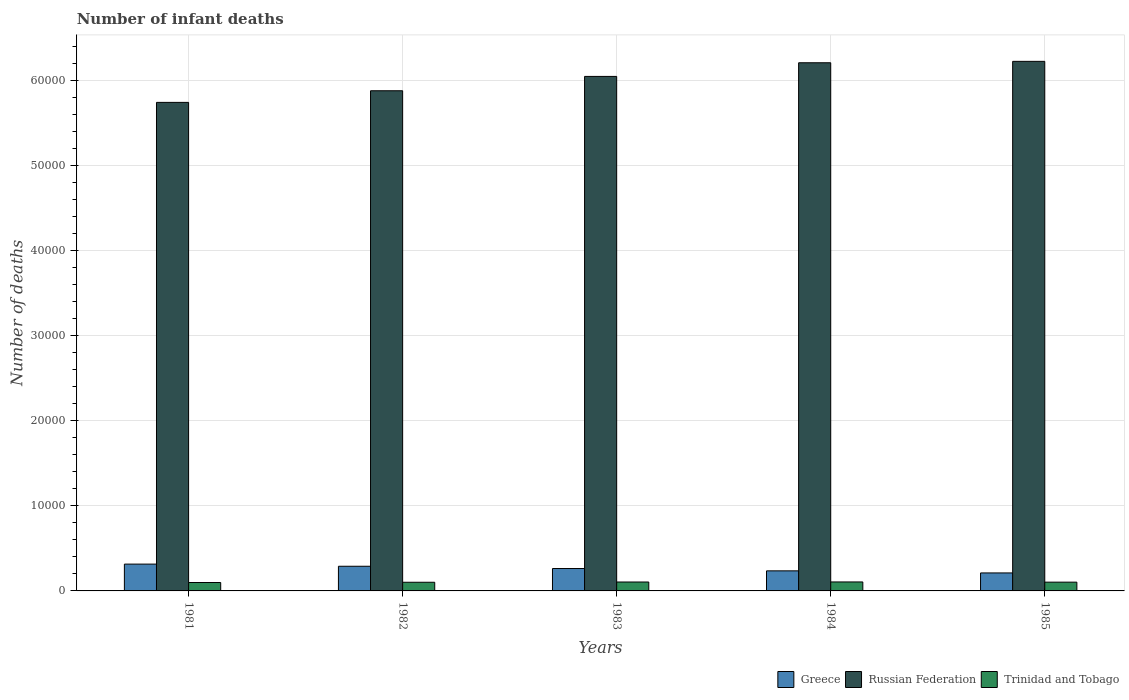How many groups of bars are there?
Keep it short and to the point. 5. Are the number of bars per tick equal to the number of legend labels?
Offer a terse response. Yes. How many bars are there on the 4th tick from the left?
Your response must be concise. 3. What is the number of infant deaths in Greece in 1983?
Your answer should be compact. 2634. Across all years, what is the maximum number of infant deaths in Russian Federation?
Make the answer very short. 6.23e+04. Across all years, what is the minimum number of infant deaths in Greece?
Keep it short and to the point. 2116. What is the total number of infant deaths in Trinidad and Tobago in the graph?
Keep it short and to the point. 5144. What is the difference between the number of infant deaths in Russian Federation in 1981 and that in 1984?
Make the answer very short. -4660. What is the difference between the number of infant deaths in Russian Federation in 1981 and the number of infant deaths in Trinidad and Tobago in 1983?
Keep it short and to the point. 5.64e+04. What is the average number of infant deaths in Greece per year?
Provide a short and direct response. 2633. In the year 1981, what is the difference between the number of infant deaths in Greece and number of infant deaths in Trinidad and Tobago?
Ensure brevity in your answer.  2164. What is the ratio of the number of infant deaths in Greece in 1982 to that in 1983?
Provide a succinct answer. 1.1. Is the number of infant deaths in Trinidad and Tobago in 1982 less than that in 1983?
Your answer should be compact. Yes. Is the difference between the number of infant deaths in Greece in 1982 and 1983 greater than the difference between the number of infant deaths in Trinidad and Tobago in 1982 and 1983?
Your answer should be compact. Yes. What is the difference between the highest and the second highest number of infant deaths in Russian Federation?
Your answer should be very brief. 165. What is the difference between the highest and the lowest number of infant deaths in Russian Federation?
Keep it short and to the point. 4825. In how many years, is the number of infant deaths in Trinidad and Tobago greater than the average number of infant deaths in Trinidad and Tobago taken over all years?
Your response must be concise. 3. What does the 3rd bar from the left in 1985 represents?
Offer a terse response. Trinidad and Tobago. What does the 2nd bar from the right in 1985 represents?
Offer a very short reply. Russian Federation. Is it the case that in every year, the sum of the number of infant deaths in Greece and number of infant deaths in Trinidad and Tobago is greater than the number of infant deaths in Russian Federation?
Make the answer very short. No. How many years are there in the graph?
Provide a succinct answer. 5. What is the difference between two consecutive major ticks on the Y-axis?
Keep it short and to the point. 10000. Are the values on the major ticks of Y-axis written in scientific E-notation?
Your response must be concise. No. Does the graph contain any zero values?
Your answer should be compact. No. Does the graph contain grids?
Your answer should be compact. Yes. How many legend labels are there?
Keep it short and to the point. 3. How are the legend labels stacked?
Ensure brevity in your answer.  Horizontal. What is the title of the graph?
Offer a very short reply. Number of infant deaths. Does "Venezuela" appear as one of the legend labels in the graph?
Keep it short and to the point. No. What is the label or title of the X-axis?
Your answer should be compact. Years. What is the label or title of the Y-axis?
Your answer should be very brief. Number of deaths. What is the Number of deaths in Greece in 1981?
Your answer should be compact. 3154. What is the Number of deaths of Russian Federation in 1981?
Make the answer very short. 5.75e+04. What is the Number of deaths in Trinidad and Tobago in 1981?
Ensure brevity in your answer.  990. What is the Number of deaths of Greece in 1982?
Ensure brevity in your answer.  2901. What is the Number of deaths in Russian Federation in 1982?
Keep it short and to the point. 5.88e+04. What is the Number of deaths of Trinidad and Tobago in 1982?
Give a very brief answer. 1019. What is the Number of deaths of Greece in 1983?
Your answer should be compact. 2634. What is the Number of deaths of Russian Federation in 1983?
Make the answer very short. 6.05e+04. What is the Number of deaths of Trinidad and Tobago in 1983?
Provide a short and direct response. 1049. What is the Number of deaths of Greece in 1984?
Your answer should be compact. 2360. What is the Number of deaths of Russian Federation in 1984?
Give a very brief answer. 6.21e+04. What is the Number of deaths of Trinidad and Tobago in 1984?
Offer a terse response. 1055. What is the Number of deaths of Greece in 1985?
Keep it short and to the point. 2116. What is the Number of deaths in Russian Federation in 1985?
Provide a succinct answer. 6.23e+04. What is the Number of deaths of Trinidad and Tobago in 1985?
Provide a short and direct response. 1031. Across all years, what is the maximum Number of deaths of Greece?
Ensure brevity in your answer.  3154. Across all years, what is the maximum Number of deaths in Russian Federation?
Your response must be concise. 6.23e+04. Across all years, what is the maximum Number of deaths in Trinidad and Tobago?
Your response must be concise. 1055. Across all years, what is the minimum Number of deaths in Greece?
Offer a terse response. 2116. Across all years, what is the minimum Number of deaths in Russian Federation?
Make the answer very short. 5.75e+04. Across all years, what is the minimum Number of deaths in Trinidad and Tobago?
Offer a very short reply. 990. What is the total Number of deaths of Greece in the graph?
Ensure brevity in your answer.  1.32e+04. What is the total Number of deaths of Russian Federation in the graph?
Provide a succinct answer. 3.01e+05. What is the total Number of deaths in Trinidad and Tobago in the graph?
Make the answer very short. 5144. What is the difference between the Number of deaths in Greece in 1981 and that in 1982?
Give a very brief answer. 253. What is the difference between the Number of deaths in Russian Federation in 1981 and that in 1982?
Your answer should be compact. -1367. What is the difference between the Number of deaths in Trinidad and Tobago in 1981 and that in 1982?
Provide a succinct answer. -29. What is the difference between the Number of deaths in Greece in 1981 and that in 1983?
Make the answer very short. 520. What is the difference between the Number of deaths in Russian Federation in 1981 and that in 1983?
Your answer should be compact. -3054. What is the difference between the Number of deaths in Trinidad and Tobago in 1981 and that in 1983?
Provide a short and direct response. -59. What is the difference between the Number of deaths in Greece in 1981 and that in 1984?
Provide a short and direct response. 794. What is the difference between the Number of deaths of Russian Federation in 1981 and that in 1984?
Give a very brief answer. -4660. What is the difference between the Number of deaths in Trinidad and Tobago in 1981 and that in 1984?
Your answer should be compact. -65. What is the difference between the Number of deaths in Greece in 1981 and that in 1985?
Your response must be concise. 1038. What is the difference between the Number of deaths of Russian Federation in 1981 and that in 1985?
Offer a terse response. -4825. What is the difference between the Number of deaths of Trinidad and Tobago in 1981 and that in 1985?
Keep it short and to the point. -41. What is the difference between the Number of deaths of Greece in 1982 and that in 1983?
Give a very brief answer. 267. What is the difference between the Number of deaths in Russian Federation in 1982 and that in 1983?
Provide a succinct answer. -1687. What is the difference between the Number of deaths in Greece in 1982 and that in 1984?
Ensure brevity in your answer.  541. What is the difference between the Number of deaths of Russian Federation in 1982 and that in 1984?
Your answer should be very brief. -3293. What is the difference between the Number of deaths of Trinidad and Tobago in 1982 and that in 1984?
Your answer should be very brief. -36. What is the difference between the Number of deaths of Greece in 1982 and that in 1985?
Ensure brevity in your answer.  785. What is the difference between the Number of deaths in Russian Federation in 1982 and that in 1985?
Your response must be concise. -3458. What is the difference between the Number of deaths in Greece in 1983 and that in 1984?
Provide a short and direct response. 274. What is the difference between the Number of deaths in Russian Federation in 1983 and that in 1984?
Make the answer very short. -1606. What is the difference between the Number of deaths of Trinidad and Tobago in 1983 and that in 1984?
Make the answer very short. -6. What is the difference between the Number of deaths in Greece in 1983 and that in 1985?
Offer a terse response. 518. What is the difference between the Number of deaths in Russian Federation in 1983 and that in 1985?
Provide a succinct answer. -1771. What is the difference between the Number of deaths in Trinidad and Tobago in 1983 and that in 1985?
Make the answer very short. 18. What is the difference between the Number of deaths in Greece in 1984 and that in 1985?
Your answer should be compact. 244. What is the difference between the Number of deaths of Russian Federation in 1984 and that in 1985?
Provide a short and direct response. -165. What is the difference between the Number of deaths in Trinidad and Tobago in 1984 and that in 1985?
Your answer should be very brief. 24. What is the difference between the Number of deaths in Greece in 1981 and the Number of deaths in Russian Federation in 1982?
Offer a terse response. -5.57e+04. What is the difference between the Number of deaths of Greece in 1981 and the Number of deaths of Trinidad and Tobago in 1982?
Provide a short and direct response. 2135. What is the difference between the Number of deaths in Russian Federation in 1981 and the Number of deaths in Trinidad and Tobago in 1982?
Give a very brief answer. 5.64e+04. What is the difference between the Number of deaths of Greece in 1981 and the Number of deaths of Russian Federation in 1983?
Ensure brevity in your answer.  -5.74e+04. What is the difference between the Number of deaths in Greece in 1981 and the Number of deaths in Trinidad and Tobago in 1983?
Offer a very short reply. 2105. What is the difference between the Number of deaths in Russian Federation in 1981 and the Number of deaths in Trinidad and Tobago in 1983?
Keep it short and to the point. 5.64e+04. What is the difference between the Number of deaths of Greece in 1981 and the Number of deaths of Russian Federation in 1984?
Offer a terse response. -5.90e+04. What is the difference between the Number of deaths in Greece in 1981 and the Number of deaths in Trinidad and Tobago in 1984?
Keep it short and to the point. 2099. What is the difference between the Number of deaths of Russian Federation in 1981 and the Number of deaths of Trinidad and Tobago in 1984?
Give a very brief answer. 5.64e+04. What is the difference between the Number of deaths in Greece in 1981 and the Number of deaths in Russian Federation in 1985?
Offer a very short reply. -5.91e+04. What is the difference between the Number of deaths of Greece in 1981 and the Number of deaths of Trinidad and Tobago in 1985?
Ensure brevity in your answer.  2123. What is the difference between the Number of deaths of Russian Federation in 1981 and the Number of deaths of Trinidad and Tobago in 1985?
Your answer should be compact. 5.64e+04. What is the difference between the Number of deaths of Greece in 1982 and the Number of deaths of Russian Federation in 1983?
Make the answer very short. -5.76e+04. What is the difference between the Number of deaths of Greece in 1982 and the Number of deaths of Trinidad and Tobago in 1983?
Your answer should be compact. 1852. What is the difference between the Number of deaths of Russian Federation in 1982 and the Number of deaths of Trinidad and Tobago in 1983?
Give a very brief answer. 5.78e+04. What is the difference between the Number of deaths of Greece in 1982 and the Number of deaths of Russian Federation in 1984?
Give a very brief answer. -5.92e+04. What is the difference between the Number of deaths in Greece in 1982 and the Number of deaths in Trinidad and Tobago in 1984?
Offer a terse response. 1846. What is the difference between the Number of deaths in Russian Federation in 1982 and the Number of deaths in Trinidad and Tobago in 1984?
Provide a short and direct response. 5.78e+04. What is the difference between the Number of deaths in Greece in 1982 and the Number of deaths in Russian Federation in 1985?
Your answer should be compact. -5.94e+04. What is the difference between the Number of deaths in Greece in 1982 and the Number of deaths in Trinidad and Tobago in 1985?
Your answer should be compact. 1870. What is the difference between the Number of deaths in Russian Federation in 1982 and the Number of deaths in Trinidad and Tobago in 1985?
Your answer should be very brief. 5.78e+04. What is the difference between the Number of deaths in Greece in 1983 and the Number of deaths in Russian Federation in 1984?
Your response must be concise. -5.95e+04. What is the difference between the Number of deaths in Greece in 1983 and the Number of deaths in Trinidad and Tobago in 1984?
Offer a very short reply. 1579. What is the difference between the Number of deaths in Russian Federation in 1983 and the Number of deaths in Trinidad and Tobago in 1984?
Offer a terse response. 5.95e+04. What is the difference between the Number of deaths in Greece in 1983 and the Number of deaths in Russian Federation in 1985?
Ensure brevity in your answer.  -5.96e+04. What is the difference between the Number of deaths in Greece in 1983 and the Number of deaths in Trinidad and Tobago in 1985?
Your response must be concise. 1603. What is the difference between the Number of deaths in Russian Federation in 1983 and the Number of deaths in Trinidad and Tobago in 1985?
Give a very brief answer. 5.95e+04. What is the difference between the Number of deaths of Greece in 1984 and the Number of deaths of Russian Federation in 1985?
Ensure brevity in your answer.  -5.99e+04. What is the difference between the Number of deaths of Greece in 1984 and the Number of deaths of Trinidad and Tobago in 1985?
Your response must be concise. 1329. What is the difference between the Number of deaths of Russian Federation in 1984 and the Number of deaths of Trinidad and Tobago in 1985?
Keep it short and to the point. 6.11e+04. What is the average Number of deaths in Greece per year?
Offer a terse response. 2633. What is the average Number of deaths in Russian Federation per year?
Your answer should be very brief. 6.02e+04. What is the average Number of deaths of Trinidad and Tobago per year?
Your answer should be very brief. 1028.8. In the year 1981, what is the difference between the Number of deaths in Greece and Number of deaths in Russian Federation?
Give a very brief answer. -5.43e+04. In the year 1981, what is the difference between the Number of deaths in Greece and Number of deaths in Trinidad and Tobago?
Give a very brief answer. 2164. In the year 1981, what is the difference between the Number of deaths in Russian Federation and Number of deaths in Trinidad and Tobago?
Keep it short and to the point. 5.65e+04. In the year 1982, what is the difference between the Number of deaths in Greece and Number of deaths in Russian Federation?
Make the answer very short. -5.59e+04. In the year 1982, what is the difference between the Number of deaths in Greece and Number of deaths in Trinidad and Tobago?
Your response must be concise. 1882. In the year 1982, what is the difference between the Number of deaths in Russian Federation and Number of deaths in Trinidad and Tobago?
Keep it short and to the point. 5.78e+04. In the year 1983, what is the difference between the Number of deaths in Greece and Number of deaths in Russian Federation?
Give a very brief answer. -5.79e+04. In the year 1983, what is the difference between the Number of deaths of Greece and Number of deaths of Trinidad and Tobago?
Keep it short and to the point. 1585. In the year 1983, what is the difference between the Number of deaths of Russian Federation and Number of deaths of Trinidad and Tobago?
Ensure brevity in your answer.  5.95e+04. In the year 1984, what is the difference between the Number of deaths in Greece and Number of deaths in Russian Federation?
Offer a very short reply. -5.98e+04. In the year 1984, what is the difference between the Number of deaths in Greece and Number of deaths in Trinidad and Tobago?
Provide a succinct answer. 1305. In the year 1984, what is the difference between the Number of deaths of Russian Federation and Number of deaths of Trinidad and Tobago?
Provide a short and direct response. 6.11e+04. In the year 1985, what is the difference between the Number of deaths of Greece and Number of deaths of Russian Federation?
Your answer should be compact. -6.02e+04. In the year 1985, what is the difference between the Number of deaths in Greece and Number of deaths in Trinidad and Tobago?
Provide a succinct answer. 1085. In the year 1985, what is the difference between the Number of deaths in Russian Federation and Number of deaths in Trinidad and Tobago?
Offer a very short reply. 6.13e+04. What is the ratio of the Number of deaths in Greece in 1981 to that in 1982?
Provide a succinct answer. 1.09. What is the ratio of the Number of deaths of Russian Federation in 1981 to that in 1982?
Offer a very short reply. 0.98. What is the ratio of the Number of deaths in Trinidad and Tobago in 1981 to that in 1982?
Provide a short and direct response. 0.97. What is the ratio of the Number of deaths of Greece in 1981 to that in 1983?
Ensure brevity in your answer.  1.2. What is the ratio of the Number of deaths in Russian Federation in 1981 to that in 1983?
Your answer should be compact. 0.95. What is the ratio of the Number of deaths in Trinidad and Tobago in 1981 to that in 1983?
Offer a very short reply. 0.94. What is the ratio of the Number of deaths of Greece in 1981 to that in 1984?
Make the answer very short. 1.34. What is the ratio of the Number of deaths in Russian Federation in 1981 to that in 1984?
Keep it short and to the point. 0.93. What is the ratio of the Number of deaths of Trinidad and Tobago in 1981 to that in 1984?
Ensure brevity in your answer.  0.94. What is the ratio of the Number of deaths in Greece in 1981 to that in 1985?
Offer a terse response. 1.49. What is the ratio of the Number of deaths in Russian Federation in 1981 to that in 1985?
Provide a succinct answer. 0.92. What is the ratio of the Number of deaths of Trinidad and Tobago in 1981 to that in 1985?
Keep it short and to the point. 0.96. What is the ratio of the Number of deaths of Greece in 1982 to that in 1983?
Give a very brief answer. 1.1. What is the ratio of the Number of deaths of Russian Federation in 1982 to that in 1983?
Make the answer very short. 0.97. What is the ratio of the Number of deaths of Trinidad and Tobago in 1982 to that in 1983?
Your answer should be compact. 0.97. What is the ratio of the Number of deaths in Greece in 1982 to that in 1984?
Provide a succinct answer. 1.23. What is the ratio of the Number of deaths of Russian Federation in 1982 to that in 1984?
Provide a succinct answer. 0.95. What is the ratio of the Number of deaths of Trinidad and Tobago in 1982 to that in 1984?
Your response must be concise. 0.97. What is the ratio of the Number of deaths of Greece in 1982 to that in 1985?
Give a very brief answer. 1.37. What is the ratio of the Number of deaths of Russian Federation in 1982 to that in 1985?
Give a very brief answer. 0.94. What is the ratio of the Number of deaths in Trinidad and Tobago in 1982 to that in 1985?
Your response must be concise. 0.99. What is the ratio of the Number of deaths in Greece in 1983 to that in 1984?
Your response must be concise. 1.12. What is the ratio of the Number of deaths in Russian Federation in 1983 to that in 1984?
Provide a short and direct response. 0.97. What is the ratio of the Number of deaths in Trinidad and Tobago in 1983 to that in 1984?
Your answer should be compact. 0.99. What is the ratio of the Number of deaths of Greece in 1983 to that in 1985?
Your answer should be very brief. 1.24. What is the ratio of the Number of deaths of Russian Federation in 1983 to that in 1985?
Your answer should be very brief. 0.97. What is the ratio of the Number of deaths in Trinidad and Tobago in 1983 to that in 1985?
Provide a short and direct response. 1.02. What is the ratio of the Number of deaths of Greece in 1984 to that in 1985?
Your answer should be compact. 1.12. What is the ratio of the Number of deaths of Trinidad and Tobago in 1984 to that in 1985?
Offer a terse response. 1.02. What is the difference between the highest and the second highest Number of deaths of Greece?
Offer a very short reply. 253. What is the difference between the highest and the second highest Number of deaths of Russian Federation?
Your response must be concise. 165. What is the difference between the highest and the lowest Number of deaths of Greece?
Offer a very short reply. 1038. What is the difference between the highest and the lowest Number of deaths of Russian Federation?
Provide a succinct answer. 4825. What is the difference between the highest and the lowest Number of deaths of Trinidad and Tobago?
Keep it short and to the point. 65. 